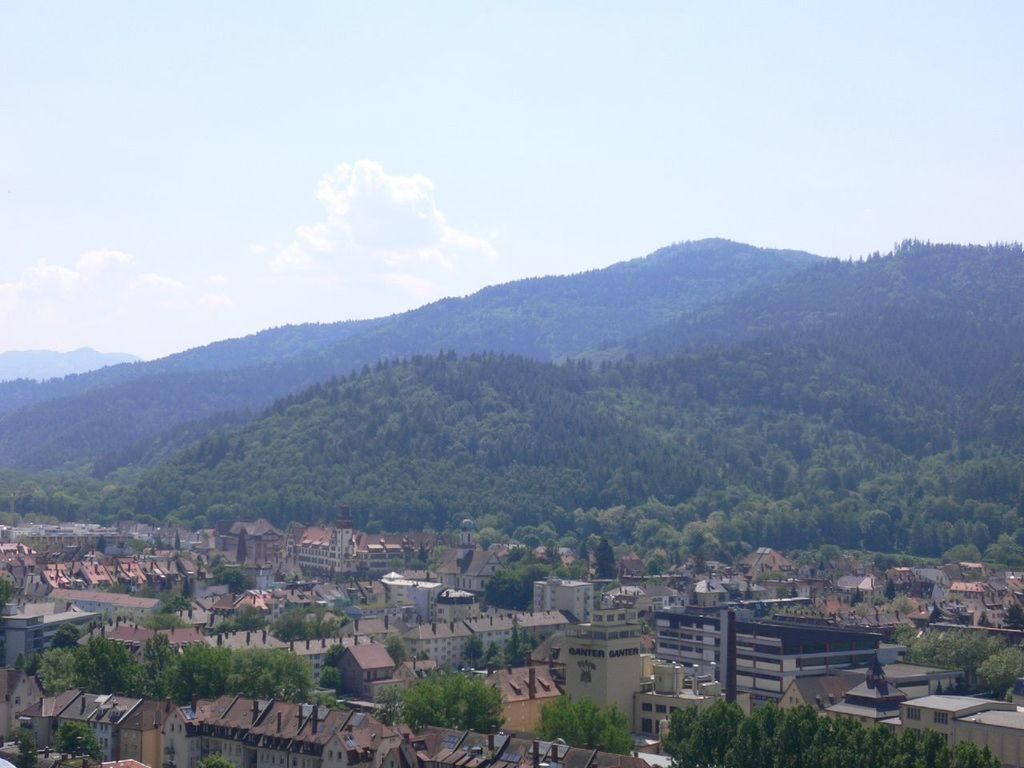What type of structures can be seen in the image? There are buildings in the image. What other natural elements are present in the image? There are trees and hills visible in the image. What is visible in the sky in the image? The sky is visible in the image, and clouds are present. Can you see a kitten making a payment to a bird in the image? No, there is no kitten or bird present in the image, and no payment is being made. 